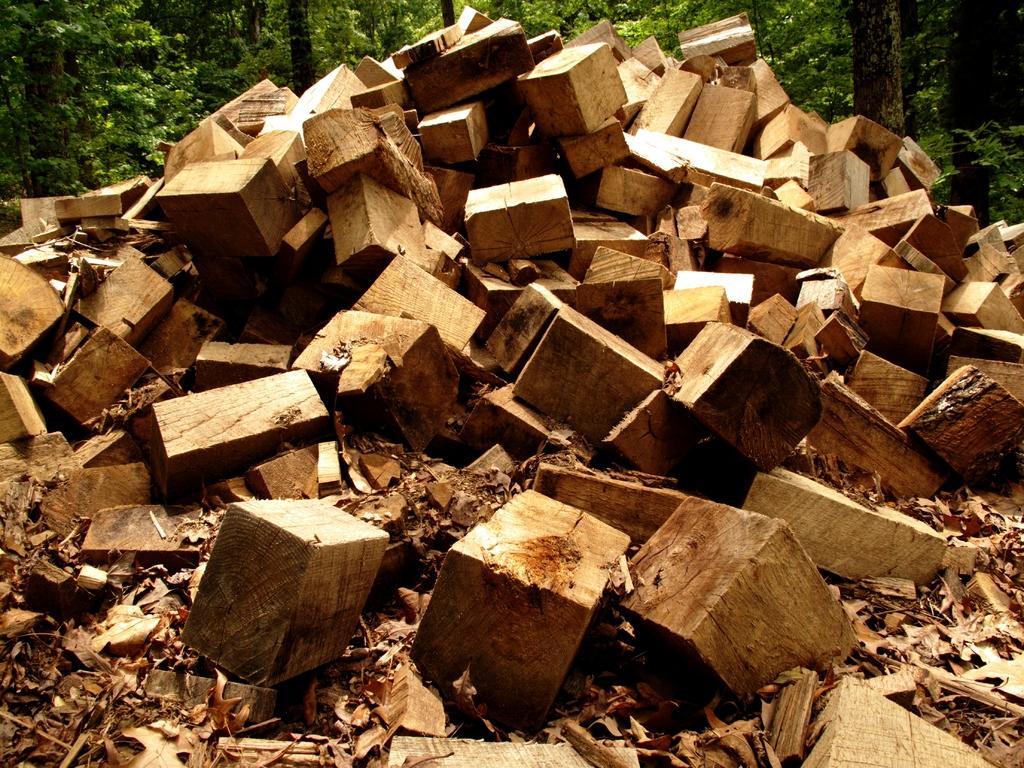How would you summarize this image in a sentence or two? In the foreground of the picture we can see wooden logs. In the background there are trees. 